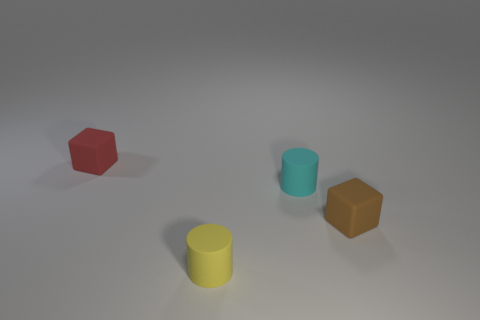Is the number of tiny matte blocks that are left of the yellow object greater than the number of red rubber blocks that are behind the small red thing?
Provide a short and direct response. Yes. There is a tiny brown matte block; are there any matte cylinders behind it?
Your answer should be very brief. Yes. There is a small rubber object that is left of the tiny yellow rubber cylinder; what shape is it?
Your response must be concise. Cube. Is there a yellow thing of the same size as the brown matte object?
Ensure brevity in your answer.  Yes. Do the cyan object that is behind the brown rubber object and the small yellow cylinder have the same material?
Offer a terse response. Yes. Are there the same number of small yellow things behind the small yellow cylinder and small brown matte cubes that are to the left of the tiny cyan matte thing?
Your answer should be very brief. Yes. There is a tiny thing that is to the left of the tiny cyan rubber object and in front of the small red matte thing; what is its shape?
Your response must be concise. Cylinder. There is a tiny red matte thing; how many tiny rubber cubes are to the right of it?
Keep it short and to the point. 1. What number of other things are the same shape as the cyan thing?
Ensure brevity in your answer.  1. Are there fewer brown things than matte blocks?
Provide a short and direct response. Yes. 